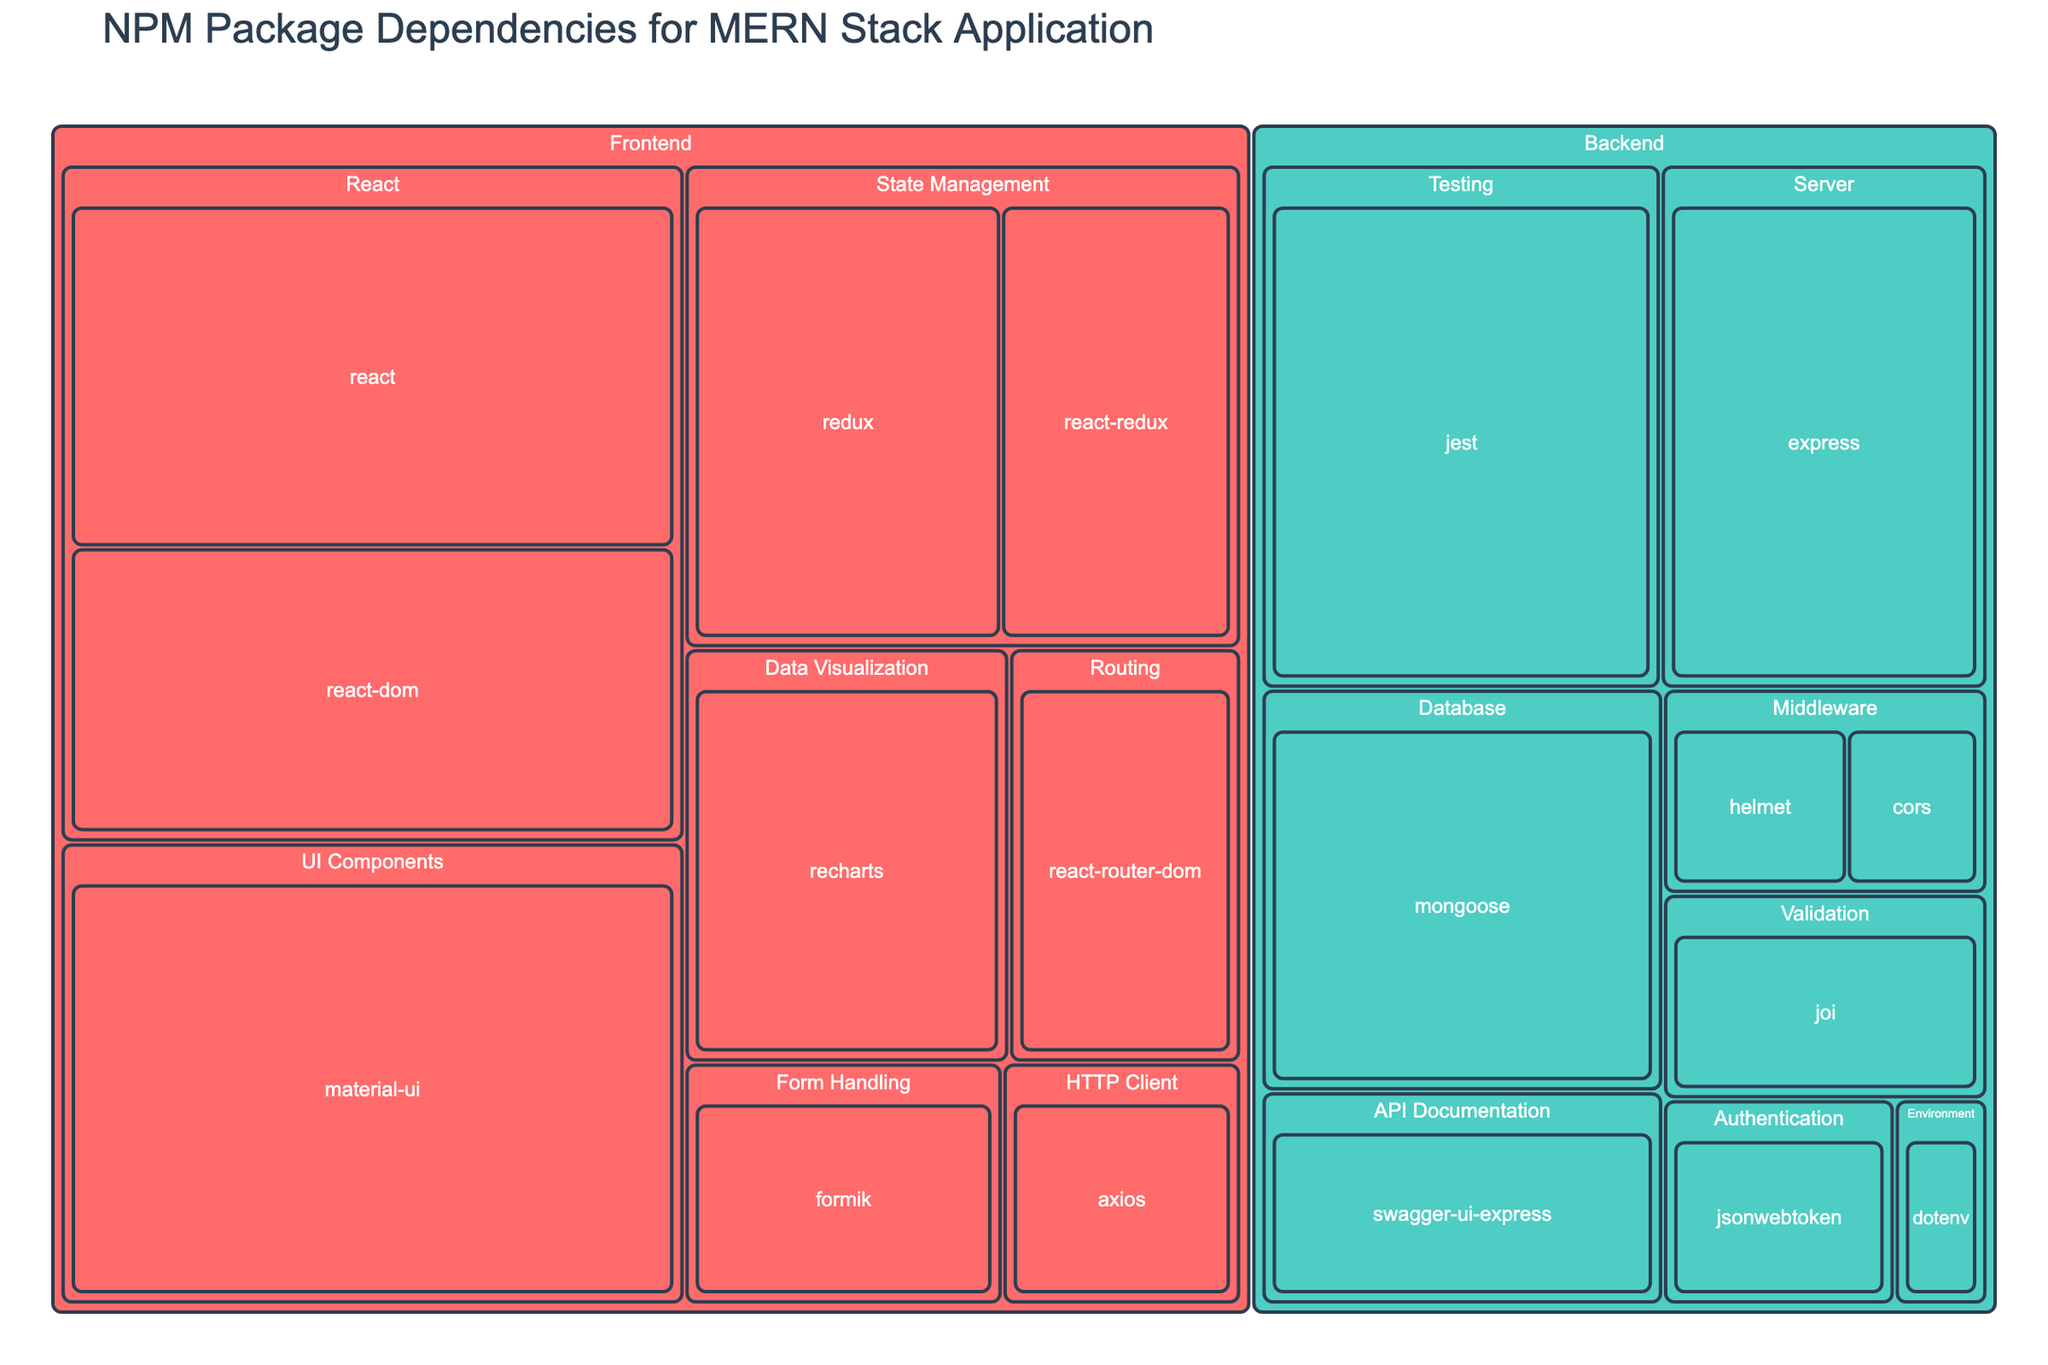What's the title of the treemap? The title is displayed at the top of the treemap and is usually in a larger font size for better visibility.
Answer: NPM Package Dependencies for MERN Stack Application Which category has more packages, Frontend or Backend? Count the number of packages listed under each category in the figure.
Answer: Frontend What is the size of the 'react' package? Locate the 'react' package in the frontend section and note the size value displayed.
Answer: 120 How much larger is 'material-ui' compared to 'axios'? Find the sizes of 'material-ui' and 'axios' and calculate their difference: 150 - 30 = 120.
Answer: 120 Which subcategory under Backend has the largest package? Identify the subcategories under Backend and compare their package sizes to find the largest one.
Answer: jest (Testing) What is the combined size of the packages in the UI Components subcategory? Add the sizes of all packages in the UI Components subcategory: 150.
Answer: 150 Which package has the smallest size, and what category is it in? Look at all package sizes and find the smallest one, noting its category.
Answer: dotenv, Backend Compare the total size of all Frontend packages to all Backend packages. Which is larger? Sum the sizes of all packages in the Frontend and Backend categories, then compare the totals. Frontend packages: 750, Backend packages: 435.
Answer: Frontend What is the average size of the packages in the Frontend category? Calculate the sum of all Frontend package sizes and divide by the number of packages: (120 + 100 + 50 + 80 + 60 + 150 + 40 + 30 + 70) / 9 = 750 / 9.
Answer: 83.33 Which subcategory contains the package with the largest size in the Frontend category? Identify the package with the largest size in the Frontend category and note its subcategory.
Answer: UI Components 